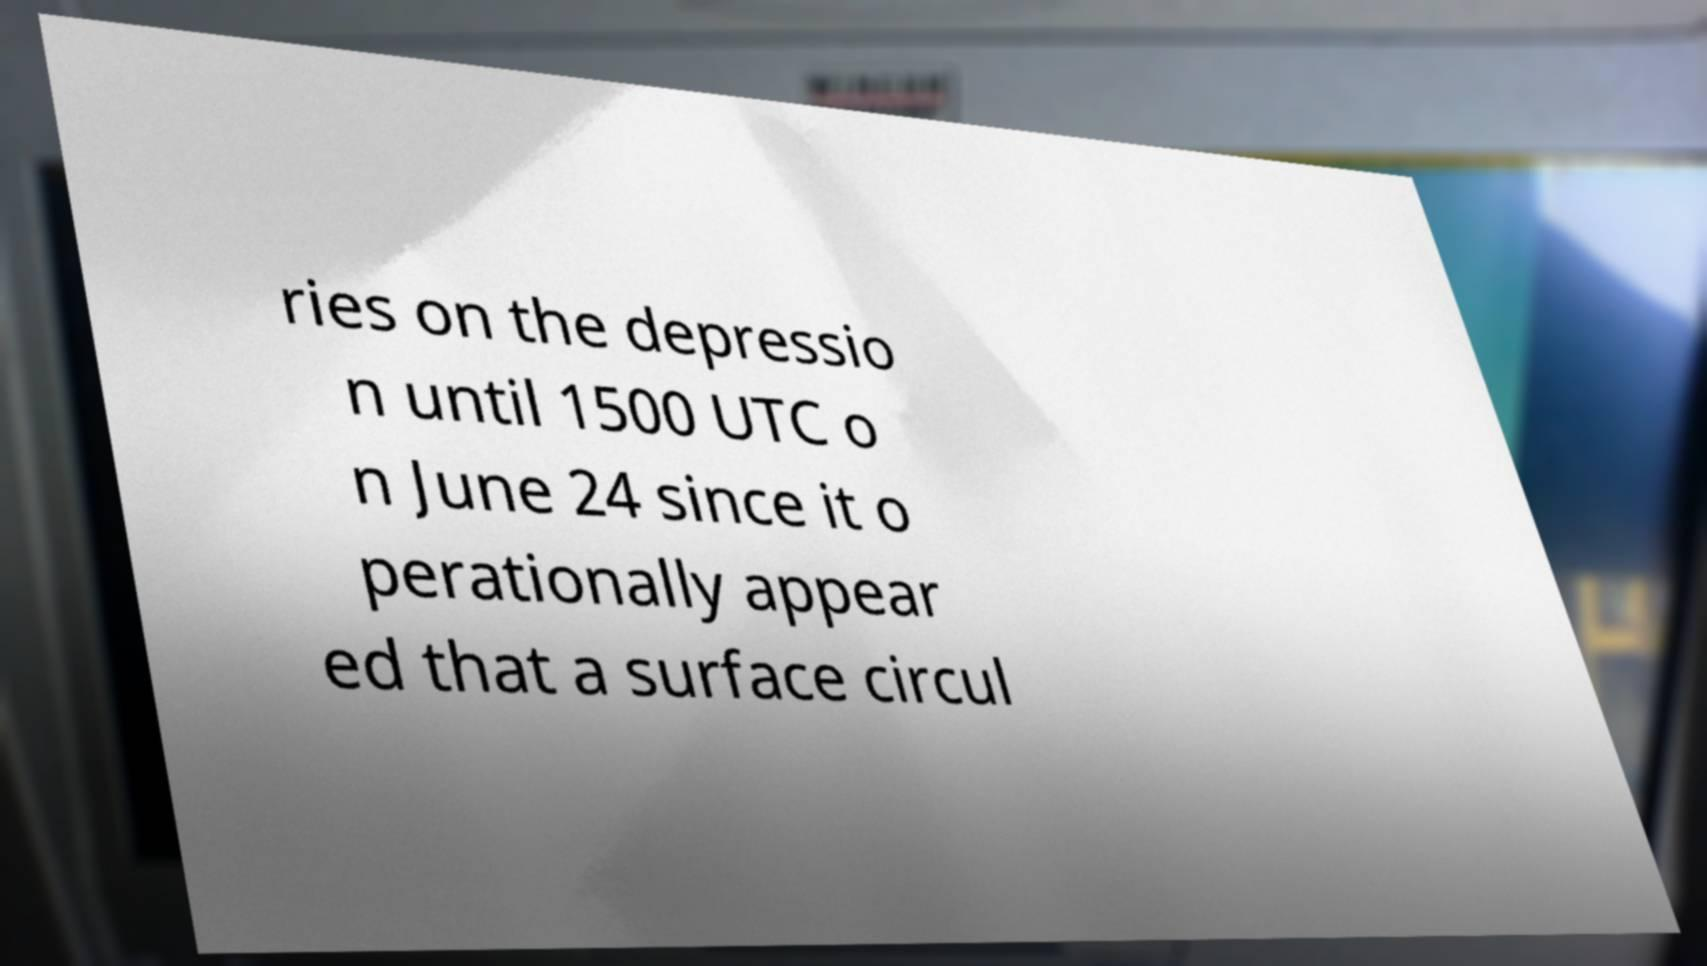Can you read and provide the text displayed in the image?This photo seems to have some interesting text. Can you extract and type it out for me? ries on the depressio n until 1500 UTC o n June 24 since it o perationally appear ed that a surface circul 